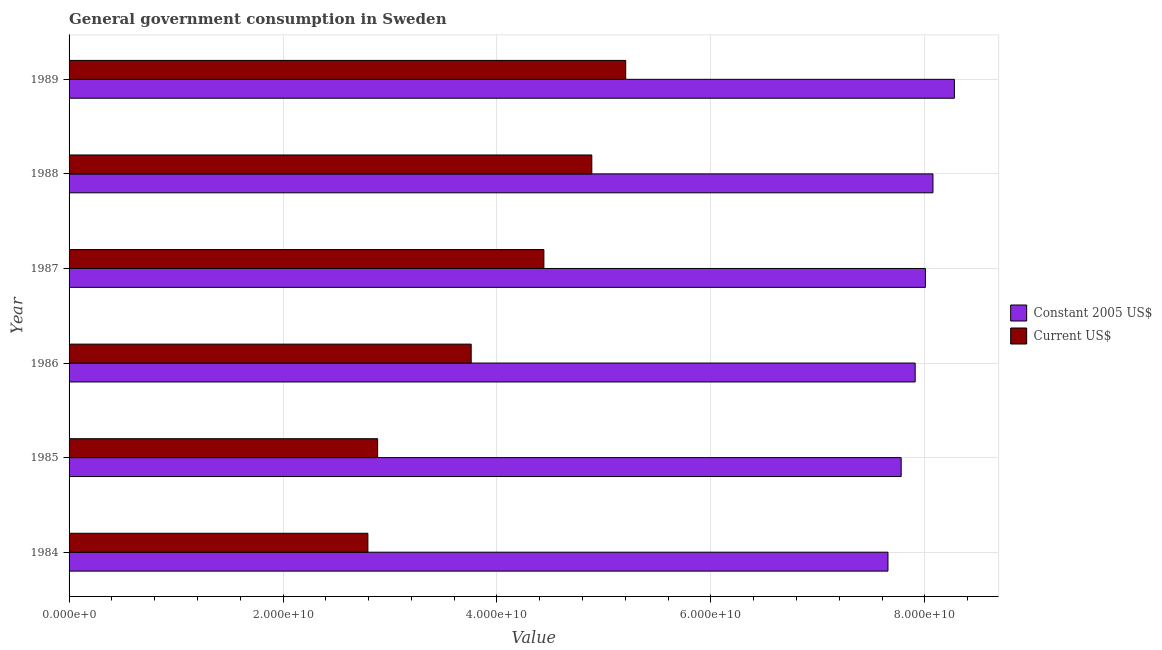Are the number of bars per tick equal to the number of legend labels?
Your answer should be very brief. Yes. Are the number of bars on each tick of the Y-axis equal?
Your response must be concise. Yes. How many bars are there on the 6th tick from the top?
Make the answer very short. 2. In how many cases, is the number of bars for a given year not equal to the number of legend labels?
Provide a succinct answer. 0. What is the value consumed in current us$ in 1985?
Provide a short and direct response. 2.88e+1. Across all years, what is the maximum value consumed in constant 2005 us$?
Provide a succinct answer. 8.28e+1. Across all years, what is the minimum value consumed in current us$?
Give a very brief answer. 2.79e+1. In which year was the value consumed in constant 2005 us$ maximum?
Make the answer very short. 1989. In which year was the value consumed in current us$ minimum?
Your response must be concise. 1984. What is the total value consumed in constant 2005 us$ in the graph?
Your response must be concise. 4.77e+11. What is the difference between the value consumed in current us$ in 1986 and that in 1988?
Give a very brief answer. -1.13e+1. What is the difference between the value consumed in constant 2005 us$ in 1987 and the value consumed in current us$ in 1988?
Give a very brief answer. 3.12e+1. What is the average value consumed in constant 2005 us$ per year?
Your answer should be compact. 7.95e+1. In the year 1984, what is the difference between the value consumed in constant 2005 us$ and value consumed in current us$?
Keep it short and to the point. 4.86e+1. What is the ratio of the value consumed in constant 2005 us$ in 1987 to that in 1988?
Your answer should be compact. 0.99. Is the value consumed in constant 2005 us$ in 1987 less than that in 1988?
Provide a short and direct response. Yes. Is the difference between the value consumed in current us$ in 1986 and 1989 greater than the difference between the value consumed in constant 2005 us$ in 1986 and 1989?
Make the answer very short. No. What is the difference between the highest and the second highest value consumed in current us$?
Provide a short and direct response. 3.17e+09. What is the difference between the highest and the lowest value consumed in current us$?
Your response must be concise. 2.41e+1. Is the sum of the value consumed in current us$ in 1984 and 1989 greater than the maximum value consumed in constant 2005 us$ across all years?
Provide a succinct answer. No. What does the 2nd bar from the top in 1984 represents?
Provide a short and direct response. Constant 2005 US$. What does the 2nd bar from the bottom in 1989 represents?
Ensure brevity in your answer.  Current US$. Are all the bars in the graph horizontal?
Offer a terse response. Yes. What is the difference between two consecutive major ticks on the X-axis?
Provide a short and direct response. 2.00e+1. Does the graph contain any zero values?
Give a very brief answer. No. Where does the legend appear in the graph?
Your response must be concise. Center right. What is the title of the graph?
Your response must be concise. General government consumption in Sweden. What is the label or title of the X-axis?
Offer a terse response. Value. What is the label or title of the Y-axis?
Provide a short and direct response. Year. What is the Value of Constant 2005 US$ in 1984?
Give a very brief answer. 7.66e+1. What is the Value of Current US$ in 1984?
Keep it short and to the point. 2.79e+1. What is the Value of Constant 2005 US$ in 1985?
Your answer should be very brief. 7.78e+1. What is the Value in Current US$ in 1985?
Provide a short and direct response. 2.88e+1. What is the Value of Constant 2005 US$ in 1986?
Provide a succinct answer. 7.91e+1. What is the Value of Current US$ in 1986?
Make the answer very short. 3.76e+1. What is the Value of Constant 2005 US$ in 1987?
Your answer should be compact. 8.01e+1. What is the Value in Current US$ in 1987?
Your answer should be compact. 4.44e+1. What is the Value in Constant 2005 US$ in 1988?
Keep it short and to the point. 8.08e+1. What is the Value of Current US$ in 1988?
Keep it short and to the point. 4.89e+1. What is the Value of Constant 2005 US$ in 1989?
Your response must be concise. 8.28e+1. What is the Value of Current US$ in 1989?
Your answer should be compact. 5.20e+1. Across all years, what is the maximum Value of Constant 2005 US$?
Your answer should be compact. 8.28e+1. Across all years, what is the maximum Value of Current US$?
Provide a succinct answer. 5.20e+1. Across all years, what is the minimum Value of Constant 2005 US$?
Ensure brevity in your answer.  7.66e+1. Across all years, what is the minimum Value of Current US$?
Offer a terse response. 2.79e+1. What is the total Value in Constant 2005 US$ in the graph?
Your response must be concise. 4.77e+11. What is the total Value of Current US$ in the graph?
Offer a terse response. 2.40e+11. What is the difference between the Value in Constant 2005 US$ in 1984 and that in 1985?
Give a very brief answer. -1.23e+09. What is the difference between the Value in Current US$ in 1984 and that in 1985?
Ensure brevity in your answer.  -9.12e+08. What is the difference between the Value in Constant 2005 US$ in 1984 and that in 1986?
Make the answer very short. -2.54e+09. What is the difference between the Value of Current US$ in 1984 and that in 1986?
Offer a terse response. -9.66e+09. What is the difference between the Value in Constant 2005 US$ in 1984 and that in 1987?
Provide a short and direct response. -3.50e+09. What is the difference between the Value of Current US$ in 1984 and that in 1987?
Offer a terse response. -1.65e+1. What is the difference between the Value of Constant 2005 US$ in 1984 and that in 1988?
Offer a very short reply. -4.21e+09. What is the difference between the Value in Current US$ in 1984 and that in 1988?
Offer a very short reply. -2.09e+1. What is the difference between the Value in Constant 2005 US$ in 1984 and that in 1989?
Keep it short and to the point. -6.21e+09. What is the difference between the Value in Current US$ in 1984 and that in 1989?
Keep it short and to the point. -2.41e+1. What is the difference between the Value of Constant 2005 US$ in 1985 and that in 1986?
Give a very brief answer. -1.31e+09. What is the difference between the Value in Current US$ in 1985 and that in 1986?
Your answer should be very brief. -8.74e+09. What is the difference between the Value in Constant 2005 US$ in 1985 and that in 1987?
Offer a terse response. -2.26e+09. What is the difference between the Value of Current US$ in 1985 and that in 1987?
Provide a short and direct response. -1.55e+1. What is the difference between the Value of Constant 2005 US$ in 1985 and that in 1988?
Offer a terse response. -2.97e+09. What is the difference between the Value in Current US$ in 1985 and that in 1988?
Ensure brevity in your answer.  -2.00e+1. What is the difference between the Value in Constant 2005 US$ in 1985 and that in 1989?
Keep it short and to the point. -4.98e+09. What is the difference between the Value in Current US$ in 1985 and that in 1989?
Provide a short and direct response. -2.32e+1. What is the difference between the Value of Constant 2005 US$ in 1986 and that in 1987?
Provide a succinct answer. -9.56e+08. What is the difference between the Value of Current US$ in 1986 and that in 1987?
Make the answer very short. -6.80e+09. What is the difference between the Value in Constant 2005 US$ in 1986 and that in 1988?
Offer a very short reply. -1.66e+09. What is the difference between the Value in Current US$ in 1986 and that in 1988?
Offer a terse response. -1.13e+1. What is the difference between the Value of Constant 2005 US$ in 1986 and that in 1989?
Your response must be concise. -3.67e+09. What is the difference between the Value of Current US$ in 1986 and that in 1989?
Ensure brevity in your answer.  -1.44e+1. What is the difference between the Value in Constant 2005 US$ in 1987 and that in 1988?
Provide a short and direct response. -7.07e+08. What is the difference between the Value of Current US$ in 1987 and that in 1988?
Give a very brief answer. -4.48e+09. What is the difference between the Value of Constant 2005 US$ in 1987 and that in 1989?
Give a very brief answer. -2.71e+09. What is the difference between the Value of Current US$ in 1987 and that in 1989?
Your answer should be compact. -7.65e+09. What is the difference between the Value in Constant 2005 US$ in 1988 and that in 1989?
Your answer should be compact. -2.00e+09. What is the difference between the Value of Current US$ in 1988 and that in 1989?
Provide a succinct answer. -3.17e+09. What is the difference between the Value of Constant 2005 US$ in 1984 and the Value of Current US$ in 1985?
Keep it short and to the point. 4.77e+1. What is the difference between the Value in Constant 2005 US$ in 1984 and the Value in Current US$ in 1986?
Give a very brief answer. 3.90e+1. What is the difference between the Value of Constant 2005 US$ in 1984 and the Value of Current US$ in 1987?
Provide a succinct answer. 3.22e+1. What is the difference between the Value of Constant 2005 US$ in 1984 and the Value of Current US$ in 1988?
Make the answer very short. 2.77e+1. What is the difference between the Value in Constant 2005 US$ in 1984 and the Value in Current US$ in 1989?
Provide a short and direct response. 2.45e+1. What is the difference between the Value in Constant 2005 US$ in 1985 and the Value in Current US$ in 1986?
Offer a terse response. 4.02e+1. What is the difference between the Value in Constant 2005 US$ in 1985 and the Value in Current US$ in 1987?
Offer a very short reply. 3.34e+1. What is the difference between the Value of Constant 2005 US$ in 1985 and the Value of Current US$ in 1988?
Make the answer very short. 2.89e+1. What is the difference between the Value of Constant 2005 US$ in 1985 and the Value of Current US$ in 1989?
Make the answer very short. 2.58e+1. What is the difference between the Value of Constant 2005 US$ in 1986 and the Value of Current US$ in 1987?
Your response must be concise. 3.47e+1. What is the difference between the Value of Constant 2005 US$ in 1986 and the Value of Current US$ in 1988?
Ensure brevity in your answer.  3.02e+1. What is the difference between the Value in Constant 2005 US$ in 1986 and the Value in Current US$ in 1989?
Offer a very short reply. 2.71e+1. What is the difference between the Value in Constant 2005 US$ in 1987 and the Value in Current US$ in 1988?
Keep it short and to the point. 3.12e+1. What is the difference between the Value of Constant 2005 US$ in 1987 and the Value of Current US$ in 1989?
Keep it short and to the point. 2.80e+1. What is the difference between the Value of Constant 2005 US$ in 1988 and the Value of Current US$ in 1989?
Your response must be concise. 2.87e+1. What is the average Value in Constant 2005 US$ per year?
Offer a terse response. 7.95e+1. What is the average Value of Current US$ per year?
Offer a terse response. 3.99e+1. In the year 1984, what is the difference between the Value of Constant 2005 US$ and Value of Current US$?
Offer a very short reply. 4.86e+1. In the year 1985, what is the difference between the Value in Constant 2005 US$ and Value in Current US$?
Offer a very short reply. 4.89e+1. In the year 1986, what is the difference between the Value of Constant 2005 US$ and Value of Current US$?
Provide a succinct answer. 4.15e+1. In the year 1987, what is the difference between the Value in Constant 2005 US$ and Value in Current US$?
Provide a succinct answer. 3.57e+1. In the year 1988, what is the difference between the Value in Constant 2005 US$ and Value in Current US$?
Your answer should be very brief. 3.19e+1. In the year 1989, what is the difference between the Value in Constant 2005 US$ and Value in Current US$?
Offer a very short reply. 3.07e+1. What is the ratio of the Value in Constant 2005 US$ in 1984 to that in 1985?
Your response must be concise. 0.98. What is the ratio of the Value in Current US$ in 1984 to that in 1985?
Your answer should be compact. 0.97. What is the ratio of the Value in Constant 2005 US$ in 1984 to that in 1986?
Your response must be concise. 0.97. What is the ratio of the Value in Current US$ in 1984 to that in 1986?
Offer a very short reply. 0.74. What is the ratio of the Value in Constant 2005 US$ in 1984 to that in 1987?
Provide a succinct answer. 0.96. What is the ratio of the Value of Current US$ in 1984 to that in 1987?
Ensure brevity in your answer.  0.63. What is the ratio of the Value in Constant 2005 US$ in 1984 to that in 1988?
Your answer should be very brief. 0.95. What is the ratio of the Value of Current US$ in 1984 to that in 1988?
Provide a succinct answer. 0.57. What is the ratio of the Value in Constant 2005 US$ in 1984 to that in 1989?
Give a very brief answer. 0.93. What is the ratio of the Value of Current US$ in 1984 to that in 1989?
Keep it short and to the point. 0.54. What is the ratio of the Value of Constant 2005 US$ in 1985 to that in 1986?
Your response must be concise. 0.98. What is the ratio of the Value of Current US$ in 1985 to that in 1986?
Keep it short and to the point. 0.77. What is the ratio of the Value in Constant 2005 US$ in 1985 to that in 1987?
Provide a short and direct response. 0.97. What is the ratio of the Value of Current US$ in 1985 to that in 1987?
Your response must be concise. 0.65. What is the ratio of the Value of Constant 2005 US$ in 1985 to that in 1988?
Ensure brevity in your answer.  0.96. What is the ratio of the Value of Current US$ in 1985 to that in 1988?
Offer a terse response. 0.59. What is the ratio of the Value of Constant 2005 US$ in 1985 to that in 1989?
Provide a succinct answer. 0.94. What is the ratio of the Value of Current US$ in 1985 to that in 1989?
Ensure brevity in your answer.  0.55. What is the ratio of the Value in Current US$ in 1986 to that in 1987?
Keep it short and to the point. 0.85. What is the ratio of the Value in Constant 2005 US$ in 1986 to that in 1988?
Provide a short and direct response. 0.98. What is the ratio of the Value of Current US$ in 1986 to that in 1988?
Provide a succinct answer. 0.77. What is the ratio of the Value in Constant 2005 US$ in 1986 to that in 1989?
Your answer should be compact. 0.96. What is the ratio of the Value in Current US$ in 1986 to that in 1989?
Your answer should be very brief. 0.72. What is the ratio of the Value in Current US$ in 1987 to that in 1988?
Keep it short and to the point. 0.91. What is the ratio of the Value in Constant 2005 US$ in 1987 to that in 1989?
Make the answer very short. 0.97. What is the ratio of the Value of Current US$ in 1987 to that in 1989?
Provide a succinct answer. 0.85. What is the ratio of the Value of Constant 2005 US$ in 1988 to that in 1989?
Your response must be concise. 0.98. What is the ratio of the Value of Current US$ in 1988 to that in 1989?
Make the answer very short. 0.94. What is the difference between the highest and the second highest Value of Constant 2005 US$?
Offer a terse response. 2.00e+09. What is the difference between the highest and the second highest Value of Current US$?
Offer a terse response. 3.17e+09. What is the difference between the highest and the lowest Value of Constant 2005 US$?
Offer a terse response. 6.21e+09. What is the difference between the highest and the lowest Value of Current US$?
Offer a very short reply. 2.41e+1. 